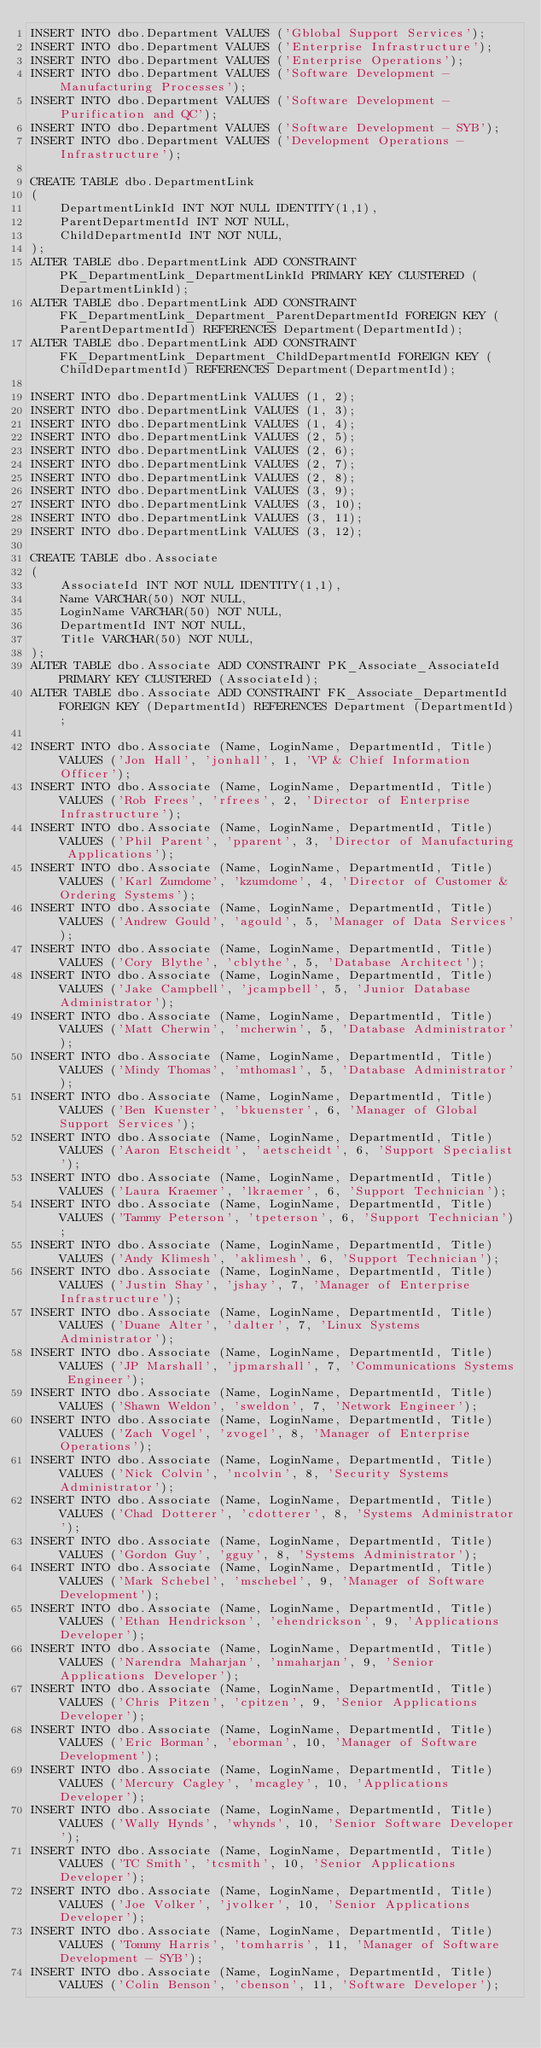Convert code to text. <code><loc_0><loc_0><loc_500><loc_500><_SQL_>INSERT INTO dbo.Department VALUES ('Gblobal Support Services');
INSERT INTO dbo.Department VALUES ('Enterprise Infrastructure');
INSERT INTO dbo.Department VALUES ('Enterprise Operations');
INSERT INTO dbo.Department VALUES ('Software Development - Manufacturing Processes');
INSERT INTO dbo.Department VALUES ('Software Development - Purification and QC');
INSERT INTO dbo.Department VALUES ('Software Development - SYB');
INSERT INTO dbo.Department VALUES ('Development Operations - Infrastructure');

CREATE TABLE dbo.DepartmentLink
(
    DepartmentLinkId INT NOT NULL IDENTITY(1,1),
    ParentDepartmentId INT NOT NULL,
    ChildDepartmentId INT NOT NULL,
);
ALTER TABLE dbo.DepartmentLink ADD CONSTRAINT PK_DepartmentLink_DepartmentLinkId PRIMARY KEY CLUSTERED (DepartmentLinkId);
ALTER TABLE dbo.DepartmentLink ADD CONSTRAINT FK_DepartmentLink_Department_ParentDepartmentId FOREIGN KEY (ParentDepartmentId) REFERENCES Department(DepartmentId);
ALTER TABLE dbo.DepartmentLink ADD CONSTRAINT FK_DepartmentLink_Department_ChildDepartmentId FOREIGN KEY (ChildDepartmentId) REFERENCES Department(DepartmentId);

INSERT INTO dbo.DepartmentLink VALUES (1, 2);
INSERT INTO dbo.DepartmentLink VALUES (1, 3);
INSERT INTO dbo.DepartmentLink VALUES (1, 4);
INSERT INTO dbo.DepartmentLink VALUES (2, 5);
INSERT INTO dbo.DepartmentLink VALUES (2, 6);
INSERT INTO dbo.DepartmentLink VALUES (2, 7);
INSERT INTO dbo.DepartmentLink VALUES (2, 8);
INSERT INTO dbo.DepartmentLink VALUES (3, 9);
INSERT INTO dbo.DepartmentLink VALUES (3, 10);
INSERT INTO dbo.DepartmentLink VALUES (3, 11);
INSERT INTO dbo.DepartmentLink VALUES (3, 12);

CREATE TABLE dbo.Associate
(
    AssociateId INT NOT NULL IDENTITY(1,1),
    Name VARCHAR(50) NOT NULL,
    LoginName VARCHAR(50) NOT NULL,
    DepartmentId INT NOT NULL,
    Title VARCHAR(50) NOT NULL,
);
ALTER TABLE dbo.Associate ADD CONSTRAINT PK_Associate_AssociateId PRIMARY KEY CLUSTERED (AssociateId);
ALTER TABLE dbo.Associate ADD CONSTRAINT FK_Associate_DepartmentId FOREIGN KEY (DepartmentId) REFERENCES Department (DepartmentId);

INSERT INTO dbo.Associate (Name, LoginName, DepartmentId, Title) VALUES ('Jon Hall', 'jonhall', 1, 'VP & Chief Information Officer');
INSERT INTO dbo.Associate (Name, LoginName, DepartmentId, Title) VALUES ('Rob Frees', 'rfrees', 2, 'Director of Enterprise Infrastructure');
INSERT INTO dbo.Associate (Name, LoginName, DepartmentId, Title) VALUES ('Phil Parent', 'pparent', 3, 'Director of Manufacturing Applications');
INSERT INTO dbo.Associate (Name, LoginName, DepartmentId, Title) VALUES ('Karl Zumdome', 'kzumdome', 4, 'Director of Customer & Ordering Systems');
INSERT INTO dbo.Associate (Name, LoginName, DepartmentId, Title) VALUES ('Andrew Gould', 'agould', 5, 'Manager of Data Services');
INSERT INTO dbo.Associate (Name, LoginName, DepartmentId, Title) VALUES ('Cory Blythe', 'cblythe', 5, 'Database Architect');
INSERT INTO dbo.Associate (Name, LoginName, DepartmentId, Title) VALUES ('Jake Campbell', 'jcampbell', 5, 'Junior Database Administrator');
INSERT INTO dbo.Associate (Name, LoginName, DepartmentId, Title) VALUES ('Matt Cherwin', 'mcherwin', 5, 'Database Administrator');
INSERT INTO dbo.Associate (Name, LoginName, DepartmentId, Title) VALUES ('Mindy Thomas', 'mthomas1', 5, 'Database Administrator');
INSERT INTO dbo.Associate (Name, LoginName, DepartmentId, Title) VALUES ('Ben Kuenster', 'bkuenster', 6, 'Manager of Global Support Services');
INSERT INTO dbo.Associate (Name, LoginName, DepartmentId, Title) VALUES ('Aaron Etscheidt', 'aetscheidt', 6, 'Support Specialist');
INSERT INTO dbo.Associate (Name, LoginName, DepartmentId, Title) VALUES ('Laura Kraemer', 'lkraemer', 6, 'Support Technician');
INSERT INTO dbo.Associate (Name, LoginName, DepartmentId, Title) VALUES ('Tammy Peterson', 'tpeterson', 6, 'Support Technician');
INSERT INTO dbo.Associate (Name, LoginName, DepartmentId, Title) VALUES ('Andy Klimesh', 'aklimesh', 6, 'Support Technician');
INSERT INTO dbo.Associate (Name, LoginName, DepartmentId, Title) VALUES ('Justin Shay', 'jshay', 7, 'Manager of Enterprise Infrastructure');
INSERT INTO dbo.Associate (Name, LoginName, DepartmentId, Title) VALUES ('Duane Alter', 'dalter', 7, 'Linux Systems Administrator');
INSERT INTO dbo.Associate (Name, LoginName, DepartmentId, Title) VALUES ('JP Marshall', 'jpmarshall', 7, 'Communications Systems Engineer');
INSERT INTO dbo.Associate (Name, LoginName, DepartmentId, Title) VALUES ('Shawn Weldon', 'sweldon', 7, 'Network Engineer');
INSERT INTO dbo.Associate (Name, LoginName, DepartmentId, Title) VALUES ('Zach Vogel', 'zvogel', 8, 'Manager of Enterprise Operations');
INSERT INTO dbo.Associate (Name, LoginName, DepartmentId, Title) VALUES ('Nick Colvin', 'ncolvin', 8, 'Security Systems Administrator');
INSERT INTO dbo.Associate (Name, LoginName, DepartmentId, Title) VALUES ('Chad Dotterer', 'cdotterer', 8, 'Systems Administrator');
INSERT INTO dbo.Associate (Name, LoginName, DepartmentId, Title) VALUES ('Gordon Guy', 'gguy', 8, 'Systems Administrator');
INSERT INTO dbo.Associate (Name, LoginName, DepartmentId, Title) VALUES ('Mark Schebel', 'mschebel', 9, 'Manager of Software Development');
INSERT INTO dbo.Associate (Name, LoginName, DepartmentId, Title) VALUES ('Ethan Hendrickson', 'ehendrickson', 9, 'Applications Developer');
INSERT INTO dbo.Associate (Name, LoginName, DepartmentId, Title) VALUES ('Narendra Maharjan', 'nmaharjan', 9, 'Senior Applications Developer');
INSERT INTO dbo.Associate (Name, LoginName, DepartmentId, Title) VALUES ('Chris Pitzen', 'cpitzen', 9, 'Senior Applications Developer');
INSERT INTO dbo.Associate (Name, LoginName, DepartmentId, Title) VALUES ('Eric Borman', 'eborman', 10, 'Manager of Software Development');
INSERT INTO dbo.Associate (Name, LoginName, DepartmentId, Title) VALUES ('Mercury Cagley', 'mcagley', 10, 'Applications Developer');
INSERT INTO dbo.Associate (Name, LoginName, DepartmentId, Title) VALUES ('Wally Hynds', 'whynds', 10, 'Senior Software Developer');
INSERT INTO dbo.Associate (Name, LoginName, DepartmentId, Title) VALUES ('TC Smith', 'tcsmith', 10, 'Senior Applications Developer');
INSERT INTO dbo.Associate (Name, LoginName, DepartmentId, Title) VALUES ('Joe Volker', 'jvolker', 10, 'Senior Applications Developer');
INSERT INTO dbo.Associate (Name, LoginName, DepartmentId, Title) VALUES ('Tommy Harris', 'tomharris', 11, 'Manager of Software Development - SYB');
INSERT INTO dbo.Associate (Name, LoginName, DepartmentId, Title) VALUES ('Colin Benson', 'cbenson', 11, 'Software Developer');</code> 